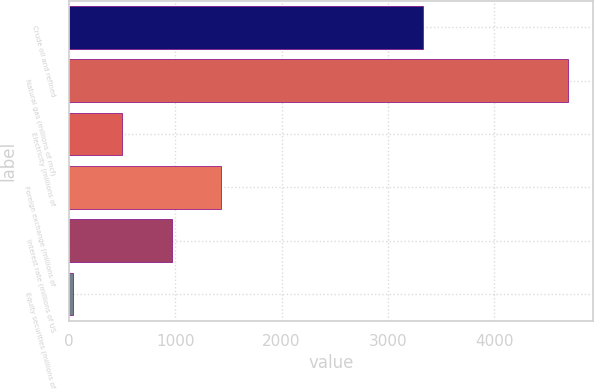<chart> <loc_0><loc_0><loc_500><loc_500><bar_chart><fcel>Crude oil and refined<fcel>Natural gas (millions of mcf)<fcel>Electricity (millions of<fcel>Foreign exchange (millions of<fcel>Interest rate (millions of US<fcel>Equity securities (millions of<nl><fcel>3328<fcel>4699<fcel>501.4<fcel>1434.2<fcel>967.8<fcel>35<nl></chart> 